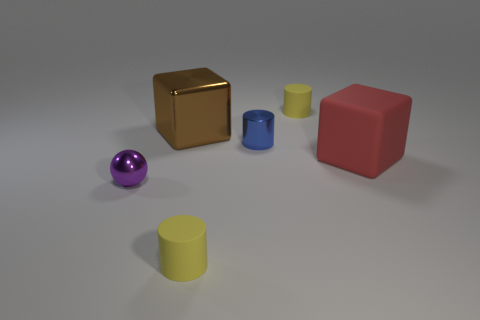Is there any other thing that has the same shape as the purple metal thing?
Provide a succinct answer. No. Is there a blue cylinder that has the same material as the small purple thing?
Offer a terse response. Yes. Is the material of the ball the same as the big red block?
Offer a very short reply. No. There is a small cylinder that is made of the same material as the small ball; what color is it?
Offer a very short reply. Blue. There is a red object that is the same shape as the large brown object; what is its material?
Provide a short and direct response. Rubber. The brown metallic object has what shape?
Provide a short and direct response. Cube. What is the thing that is both in front of the large brown metal thing and right of the blue cylinder made of?
Your answer should be compact. Rubber. The tiny object that is made of the same material as the small sphere is what shape?
Your response must be concise. Cylinder. There is a cylinder that is the same material as the ball; what is its size?
Keep it short and to the point. Small. There is a metallic thing that is left of the metallic cylinder and behind the big rubber cube; what shape is it?
Give a very brief answer. Cube. 